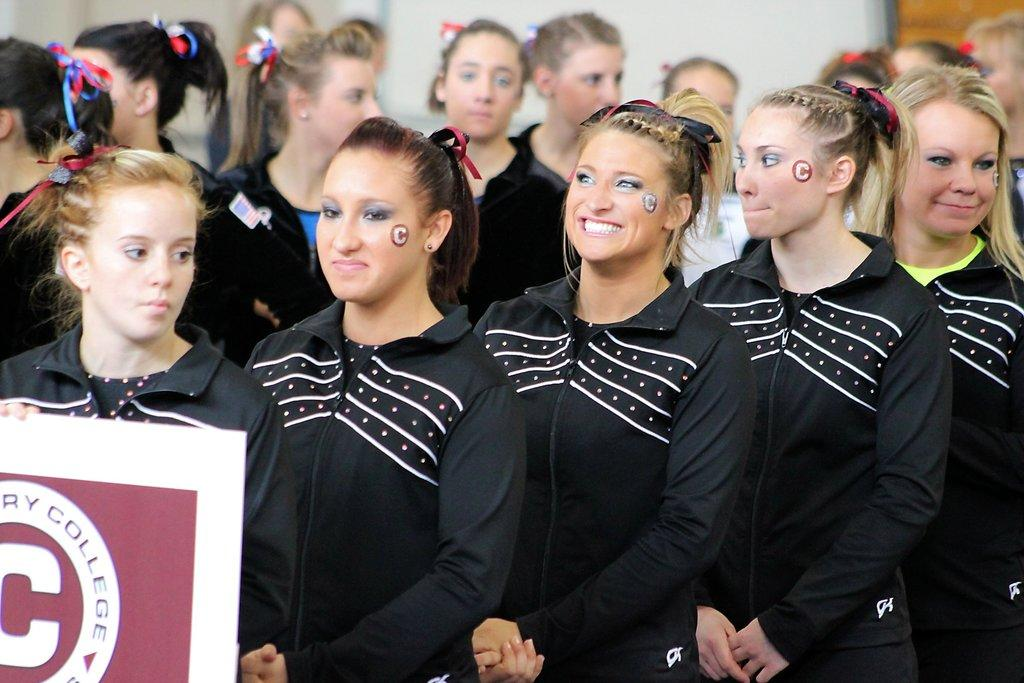What is happening in the image? There are women standing in the image. Can you describe what one of the women is holding? One woman is holding a board. What can be observed about the background of the image? The background of the image is blurry. Is the sun visible in the image? There is no mention of the sun or any celestial bodies in the provided facts, so it cannot be determined if the sun is visible in the image. 